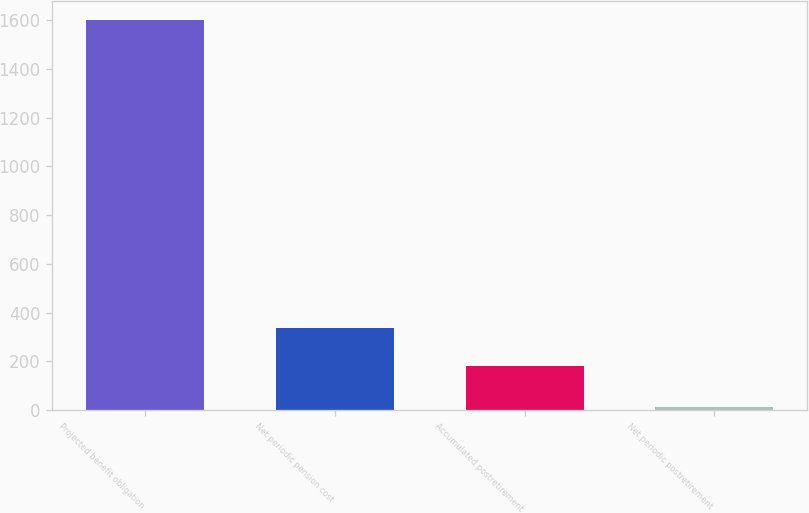<chart> <loc_0><loc_0><loc_500><loc_500><bar_chart><fcel>Projected benefit obligation<fcel>Net periodic pension cost<fcel>Accumulated postretirement<fcel>Net periodic postretirement<nl><fcel>1599<fcel>338.5<fcel>180<fcel>14<nl></chart> 